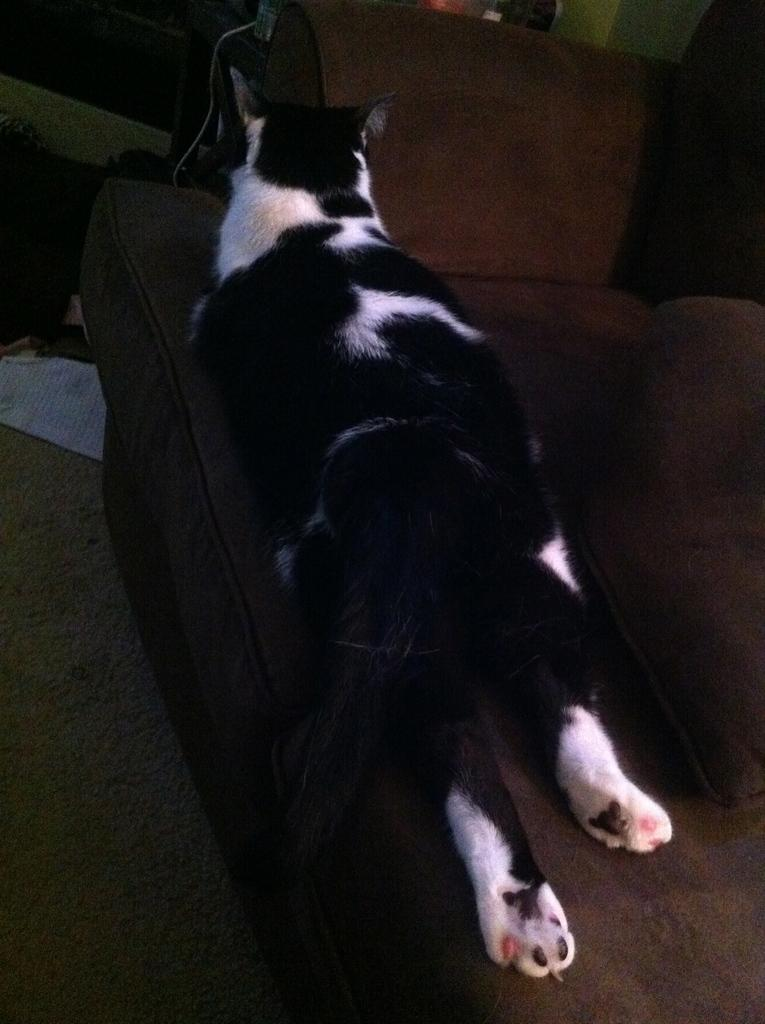What animal is laying on the couch in the image? There is a cat laying on the couch in the image. What can be seen on the ground in the image? There is a white object on the ground in the image. What is visible in the background of the image? There are objects visible in the background of the image. What type of library is depicted in the background of the image? There is no library visible in the background of the image. What is the value of the silver object on the ground in the image? There is no silver object present in the image. 